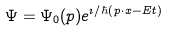Convert formula to latex. <formula><loc_0><loc_0><loc_500><loc_500>\Psi = \Psi _ { 0 } ( p ) e ^ { \imath / \hbar { ( } p \cdot x - E t ) }</formula> 